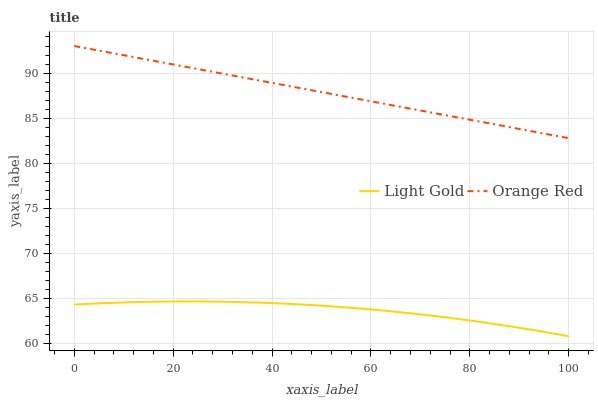Does Orange Red have the minimum area under the curve?
Answer yes or no. No. Is Orange Red the roughest?
Answer yes or no. No. Does Orange Red have the lowest value?
Answer yes or no. No. Is Light Gold less than Orange Red?
Answer yes or no. Yes. Is Orange Red greater than Light Gold?
Answer yes or no. Yes. Does Light Gold intersect Orange Red?
Answer yes or no. No. 